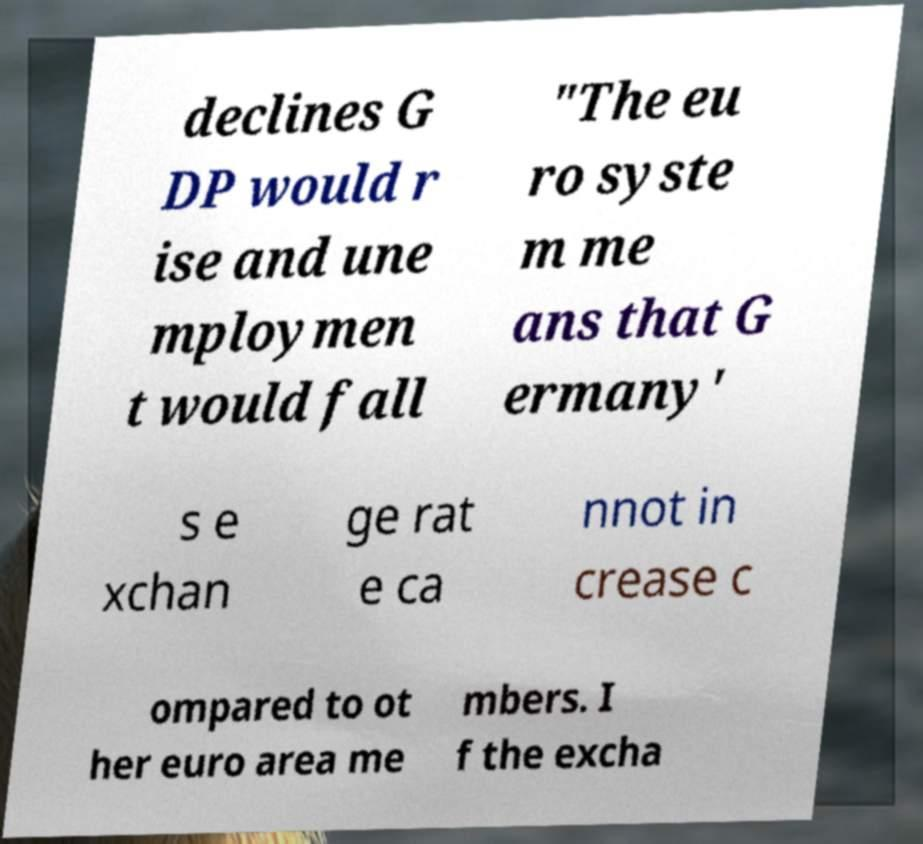Please identify and transcribe the text found in this image. declines G DP would r ise and une mploymen t would fall "The eu ro syste m me ans that G ermany' s e xchan ge rat e ca nnot in crease c ompared to ot her euro area me mbers. I f the excha 